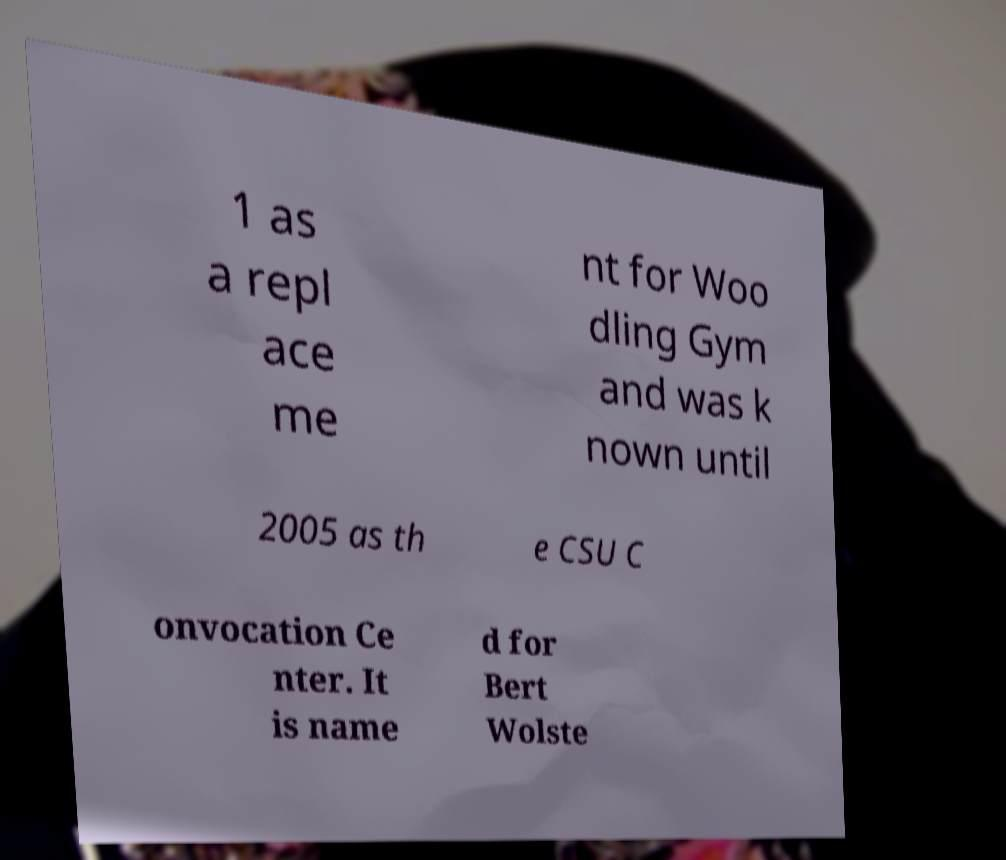Could you extract and type out the text from this image? 1 as a repl ace me nt for Woo dling Gym and was k nown until 2005 as th e CSU C onvocation Ce nter. It is name d for Bert Wolste 